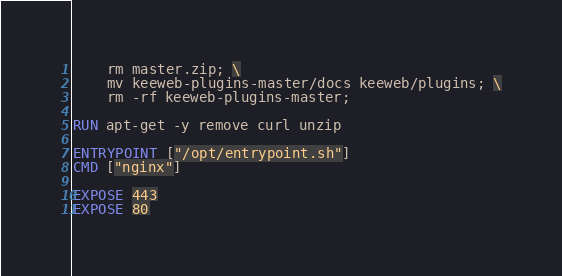<code> <loc_0><loc_0><loc_500><loc_500><_Dockerfile_>    rm master.zip; \
    mv keeweb-plugins-master/docs keeweb/plugins; \
    rm -rf keeweb-plugins-master;

RUN apt-get -y remove curl unzip

ENTRYPOINT ["/opt/entrypoint.sh"]
CMD ["nginx"]

EXPOSE 443
EXPOSE 80
</code> 